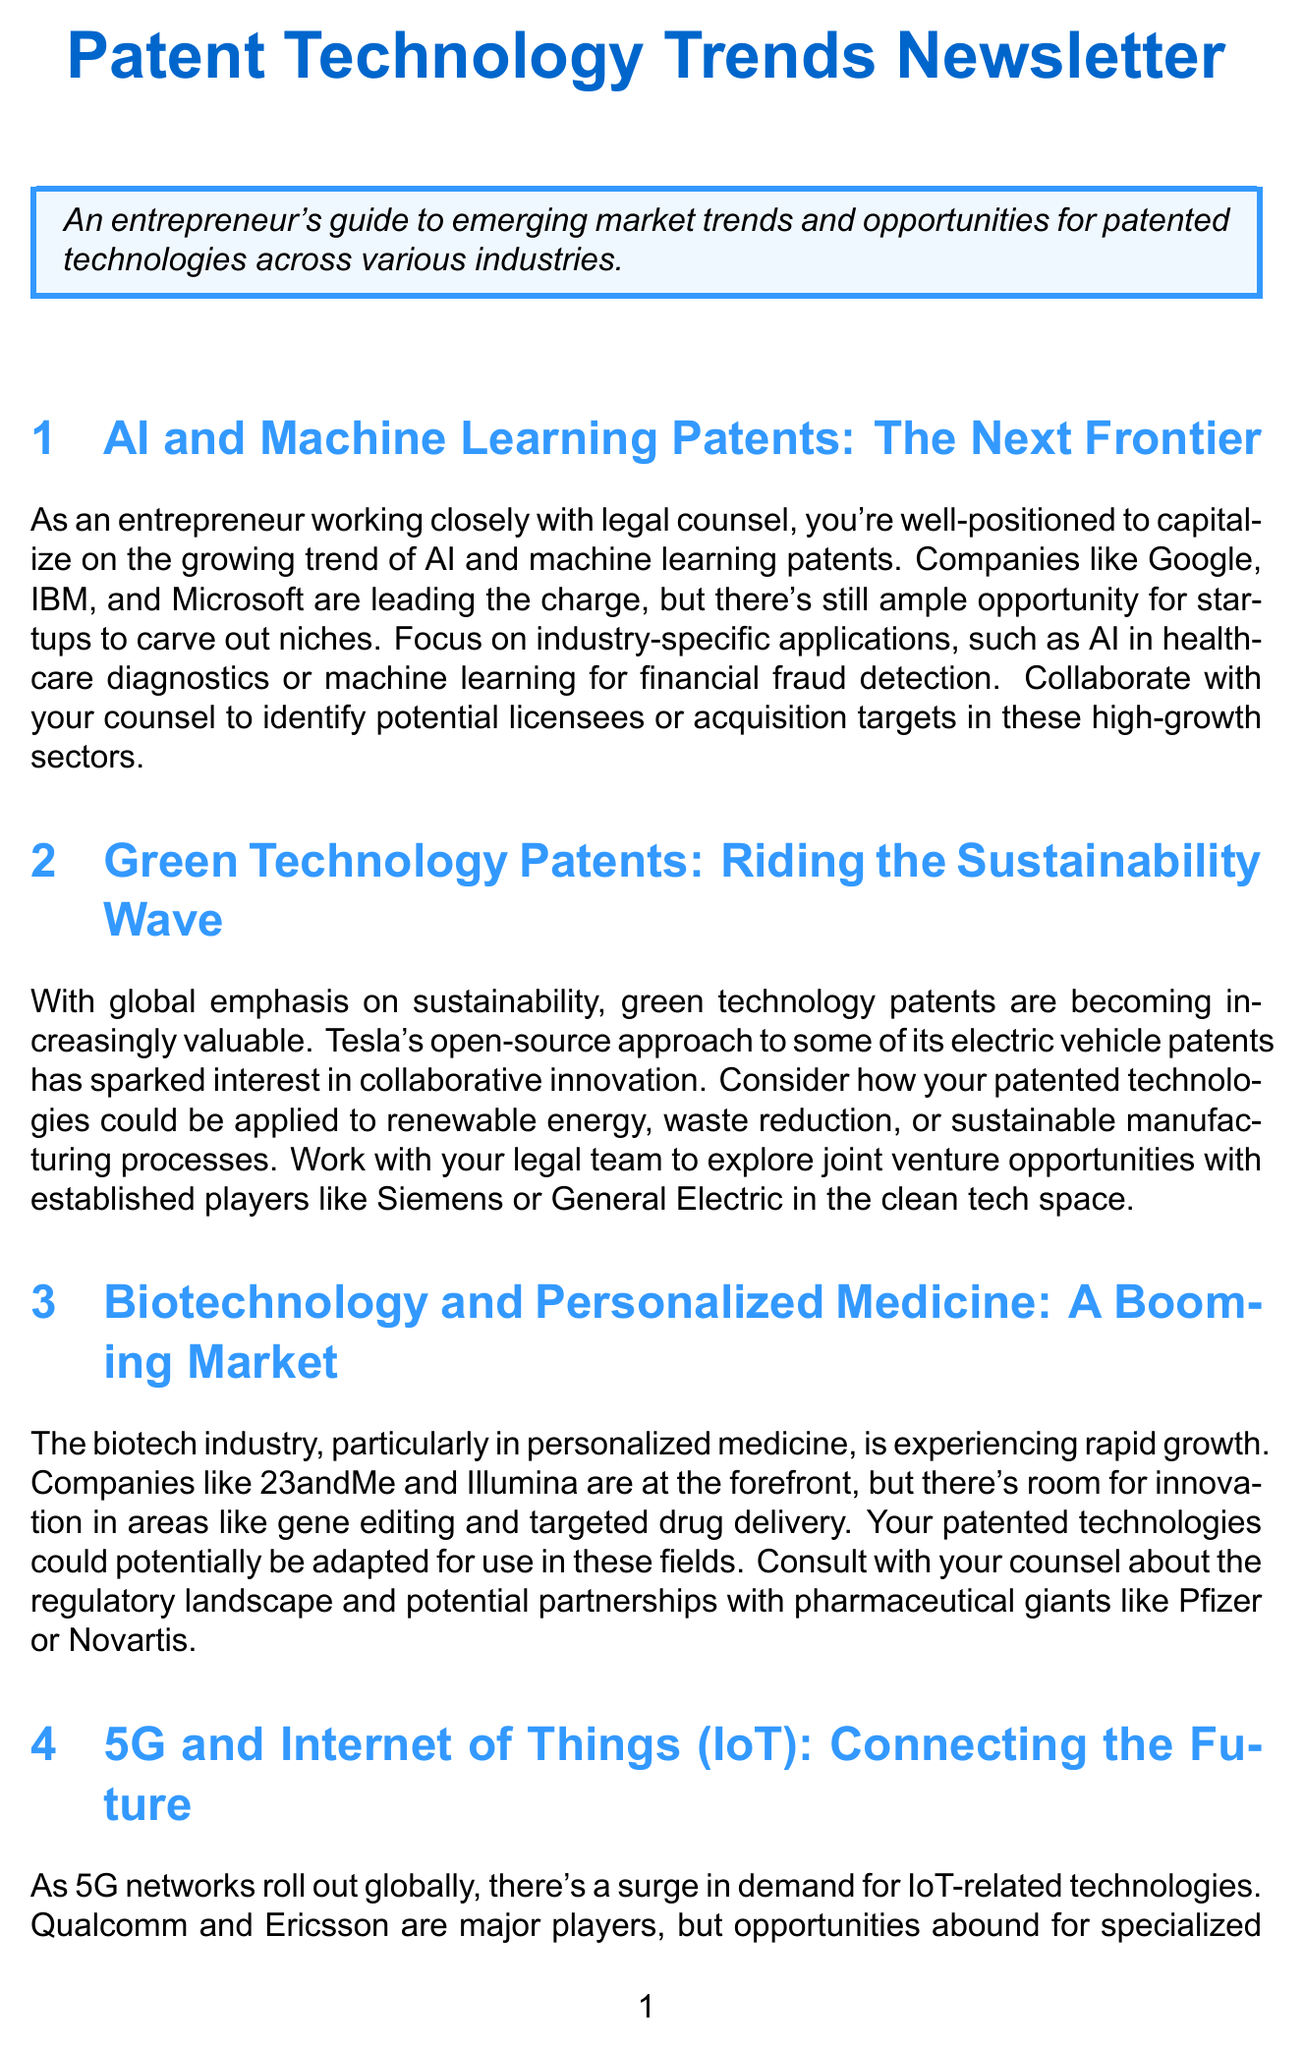What are some industry-specific applications of AI? The document lists AI in healthcare diagnostics and machine learning for financial fraud detection as examples of industry-specific applications.
Answer: healthcare diagnostics, financial fraud detection Which companies are identified as major players in green technology patents? The document mentions Tesla, Siemens, and General Electric as significant players in the green technology space.
Answer: Tesla, Siemens, General Electric What is the key growth area in biotechnology mentioned? The newsletter highlights personalized medicine as a rapidly growing area in the biotech industry.
Answer: personalized medicine What technology is expected to enhance smart home devices? The document suggests that patents related to IoT technologies are expected to enhance smart home devices.
Answer: IoT technologies What is a potential partnership mentioned for augmented and virtual reality innovations? The newsletter suggests exploring partnerships with tech giants and industry-specific companies for AR/VR technologies.
Answer: tech giants, industry-specific companies Which company is said to offer blockchain-as-a-service? The document mentions IBM and Amazon Web Services as providers of blockchain-as-a-service.
Answer: IBM, Amazon Web Services What is suggested for startups interested in AI and machine learning patents? The document suggests focusing on industry-specific applications for startups interested in AI and machine learning patents.
Answer: industry-specific applications What opportunity does the newsletter suggest for green technology patents? The document suggests exploring joint venture opportunities in the clean tech space for green technology patents.
Answer: joint venture opportunities Who should entrepreneurs collaborate with when seeking opportunities in patented technologies? The newsletter emphasizes the importance of working with legal counsel when pursuing opportunities in patented technologies.
Answer: legal counsel 